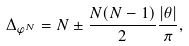<formula> <loc_0><loc_0><loc_500><loc_500>\Delta _ { \varphi ^ { N } } = N \pm \frac { N ( N - 1 ) } 2 \frac { | \theta | } \pi ,</formula> 